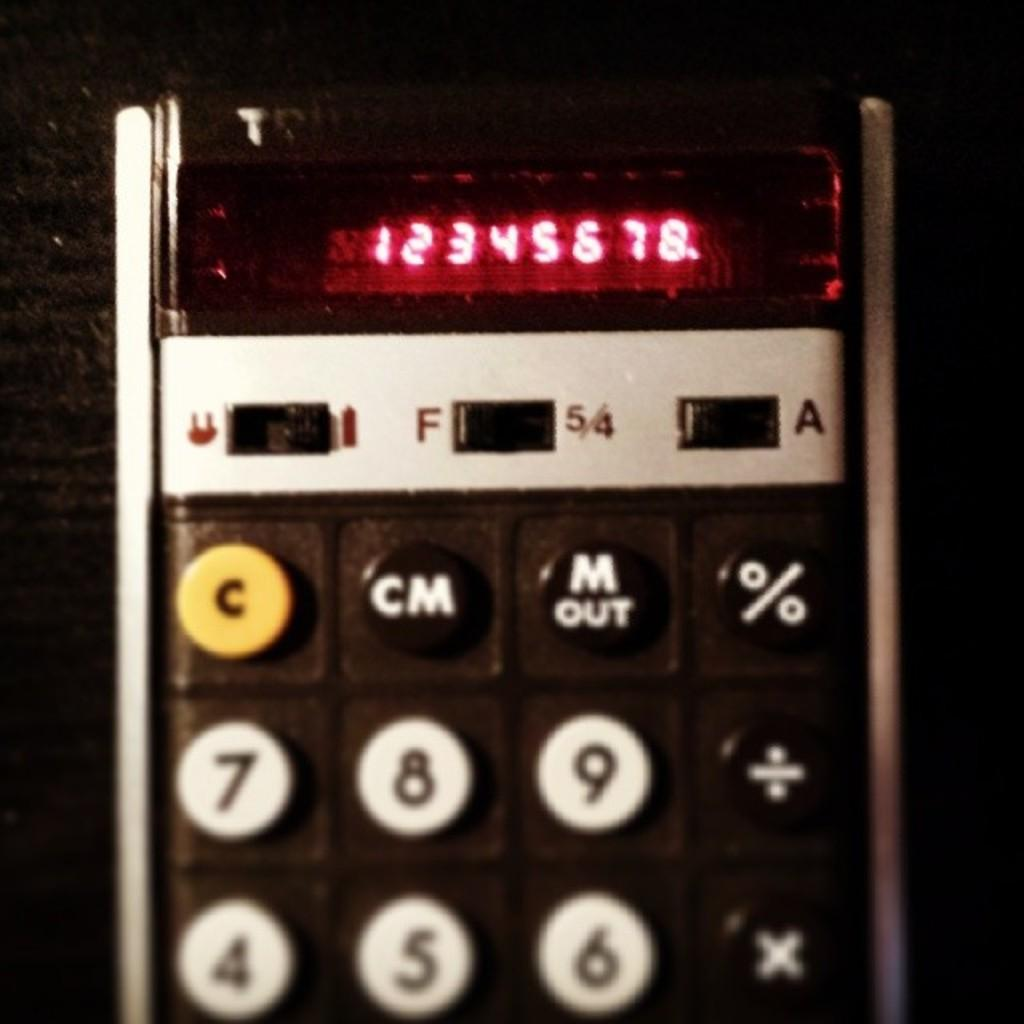<image>
Write a terse but informative summary of the picture. An old calculator with buttons such as C, CM and M out. 